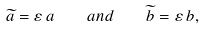<formula> <loc_0><loc_0><loc_500><loc_500>\widetilde { a } = \varepsilon \, a \quad a n d \quad \widetilde { b } = \varepsilon \, b ,</formula> 